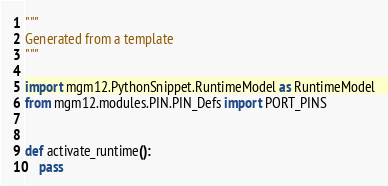Convert code to text. <code><loc_0><loc_0><loc_500><loc_500><_Python_>"""
Generated from a template
"""

import mgm12.PythonSnippet.RuntimeModel as RuntimeModel
from mgm12.modules.PIN.PIN_Defs import PORT_PINS


def activate_runtime():
    pass






</code> 